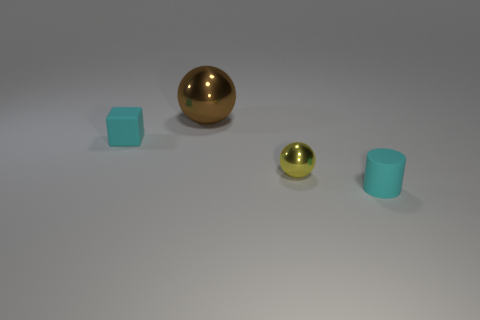What size is the object that is to the right of the brown thing and left of the small cylinder?
Provide a short and direct response. Small. There is a ball that is the same size as the cyan cylinder; what is its material?
Keep it short and to the point. Metal. There is a rubber thing to the right of the cyan rubber object to the left of the brown metal thing; how many tiny yellow spheres are in front of it?
Give a very brief answer. 0. There is a tiny thing to the left of the yellow metal sphere; is its color the same as the metallic sphere on the right side of the big ball?
Offer a terse response. No. What color is the small thing that is behind the tiny cyan cylinder and in front of the tiny cyan matte cube?
Provide a short and direct response. Yellow. What number of gray rubber blocks are the same size as the cylinder?
Provide a short and direct response. 0. There is a matte object that is behind the small cyan rubber object right of the large brown metal object; what shape is it?
Keep it short and to the point. Cube. The rubber object on the right side of the tiny rubber object behind the tiny matte thing that is to the right of the large shiny sphere is what shape?
Your response must be concise. Cylinder. What number of other tiny yellow objects are the same shape as the yellow thing?
Ensure brevity in your answer.  0. What number of cyan things are to the left of the tiny cyan object right of the cyan rubber block?
Offer a terse response. 1. 